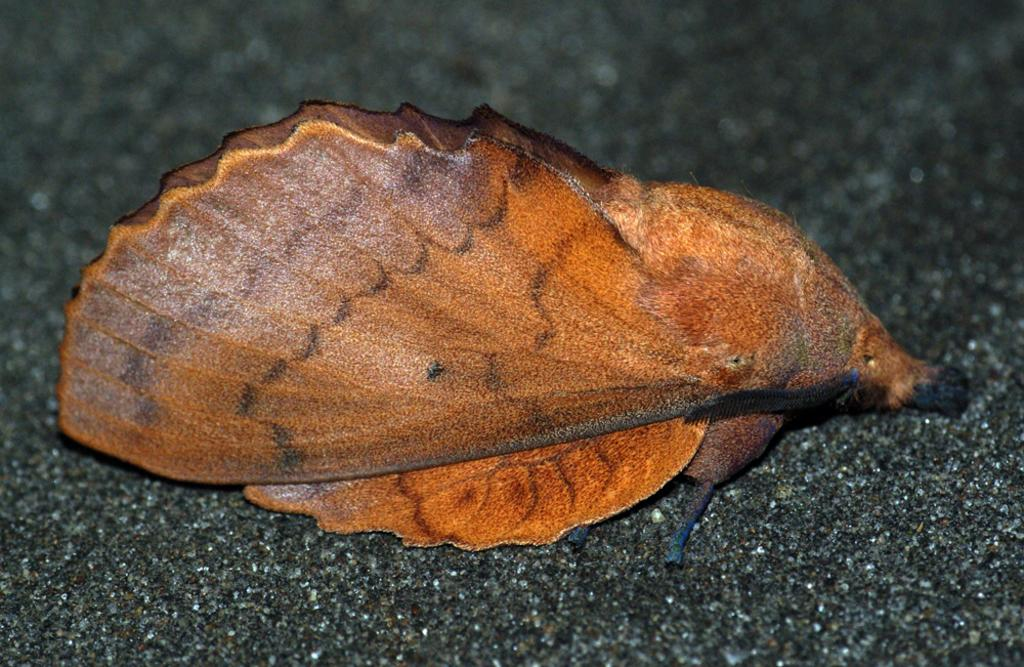What is the main subject in the center of the image? There is a brown color thing in the center of the image. Can you describe the appearance of the main subject? The brown color thing is blurred in the image. What type of punishment is being depicted in the image? There is no punishment depicted in the image; it only features a blurred brown color thing. What decision is being made by the blurred brown color thing in the image? There is no decision being made by the blurred brown color thing in the image, as it is not an animate or sentient object. 